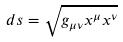Convert formula to latex. <formula><loc_0><loc_0><loc_500><loc_500>d s = \sqrt { g _ { \mu \nu } x ^ { \mu } x ^ { \nu } } \,</formula> 